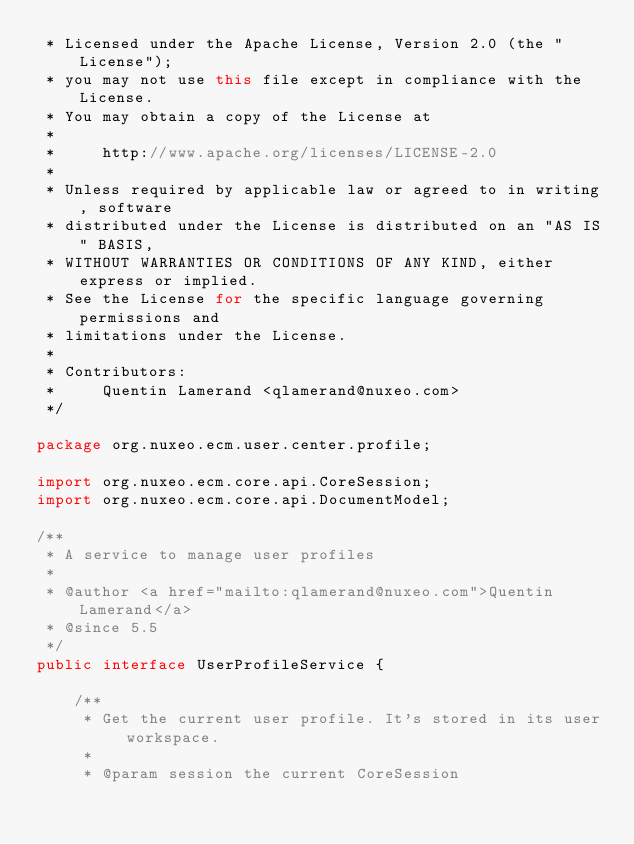Convert code to text. <code><loc_0><loc_0><loc_500><loc_500><_Java_> * Licensed under the Apache License, Version 2.0 (the "License");
 * you may not use this file except in compliance with the License.
 * You may obtain a copy of the License at
 *
 *     http://www.apache.org/licenses/LICENSE-2.0
 *
 * Unless required by applicable law or agreed to in writing, software
 * distributed under the License is distributed on an "AS IS" BASIS,
 * WITHOUT WARRANTIES OR CONDITIONS OF ANY KIND, either express or implied.
 * See the License for the specific language governing permissions and
 * limitations under the License.
 *
 * Contributors:
 *     Quentin Lamerand <qlamerand@nuxeo.com>
 */

package org.nuxeo.ecm.user.center.profile;

import org.nuxeo.ecm.core.api.CoreSession;
import org.nuxeo.ecm.core.api.DocumentModel;

/**
 * A service to manage user profiles
 *
 * @author <a href="mailto:qlamerand@nuxeo.com">Quentin Lamerand</a>
 * @since 5.5
 */
public interface UserProfileService {

    /**
     * Get the current user profile. It's stored in its user workspace.
     *
     * @param session the current CoreSession</code> 